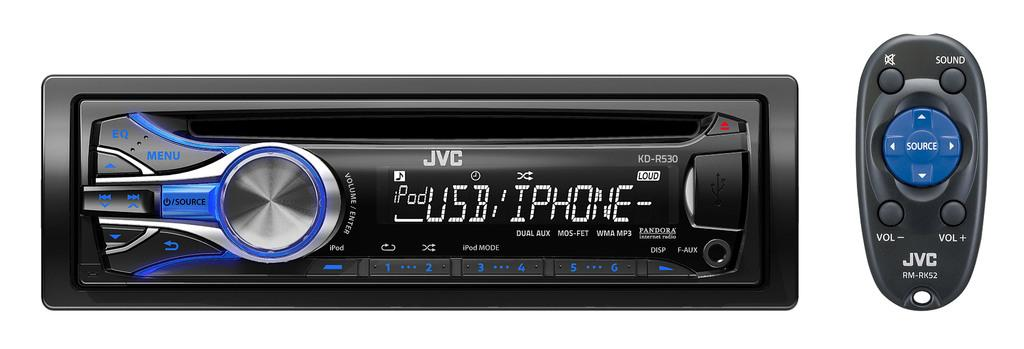<image>
Render a clear and concise summary of the photo. the car radio display shows that is connects to a phone with usb 